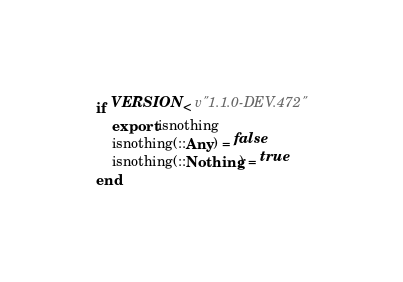<code> <loc_0><loc_0><loc_500><loc_500><_Julia_>if VERSION < v"1.1.0-DEV.472"
    export isnothing
    isnothing(::Any) = false
    isnothing(::Nothing) = true
end
</code> 